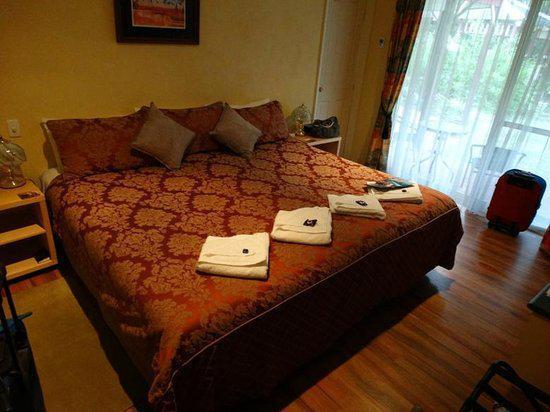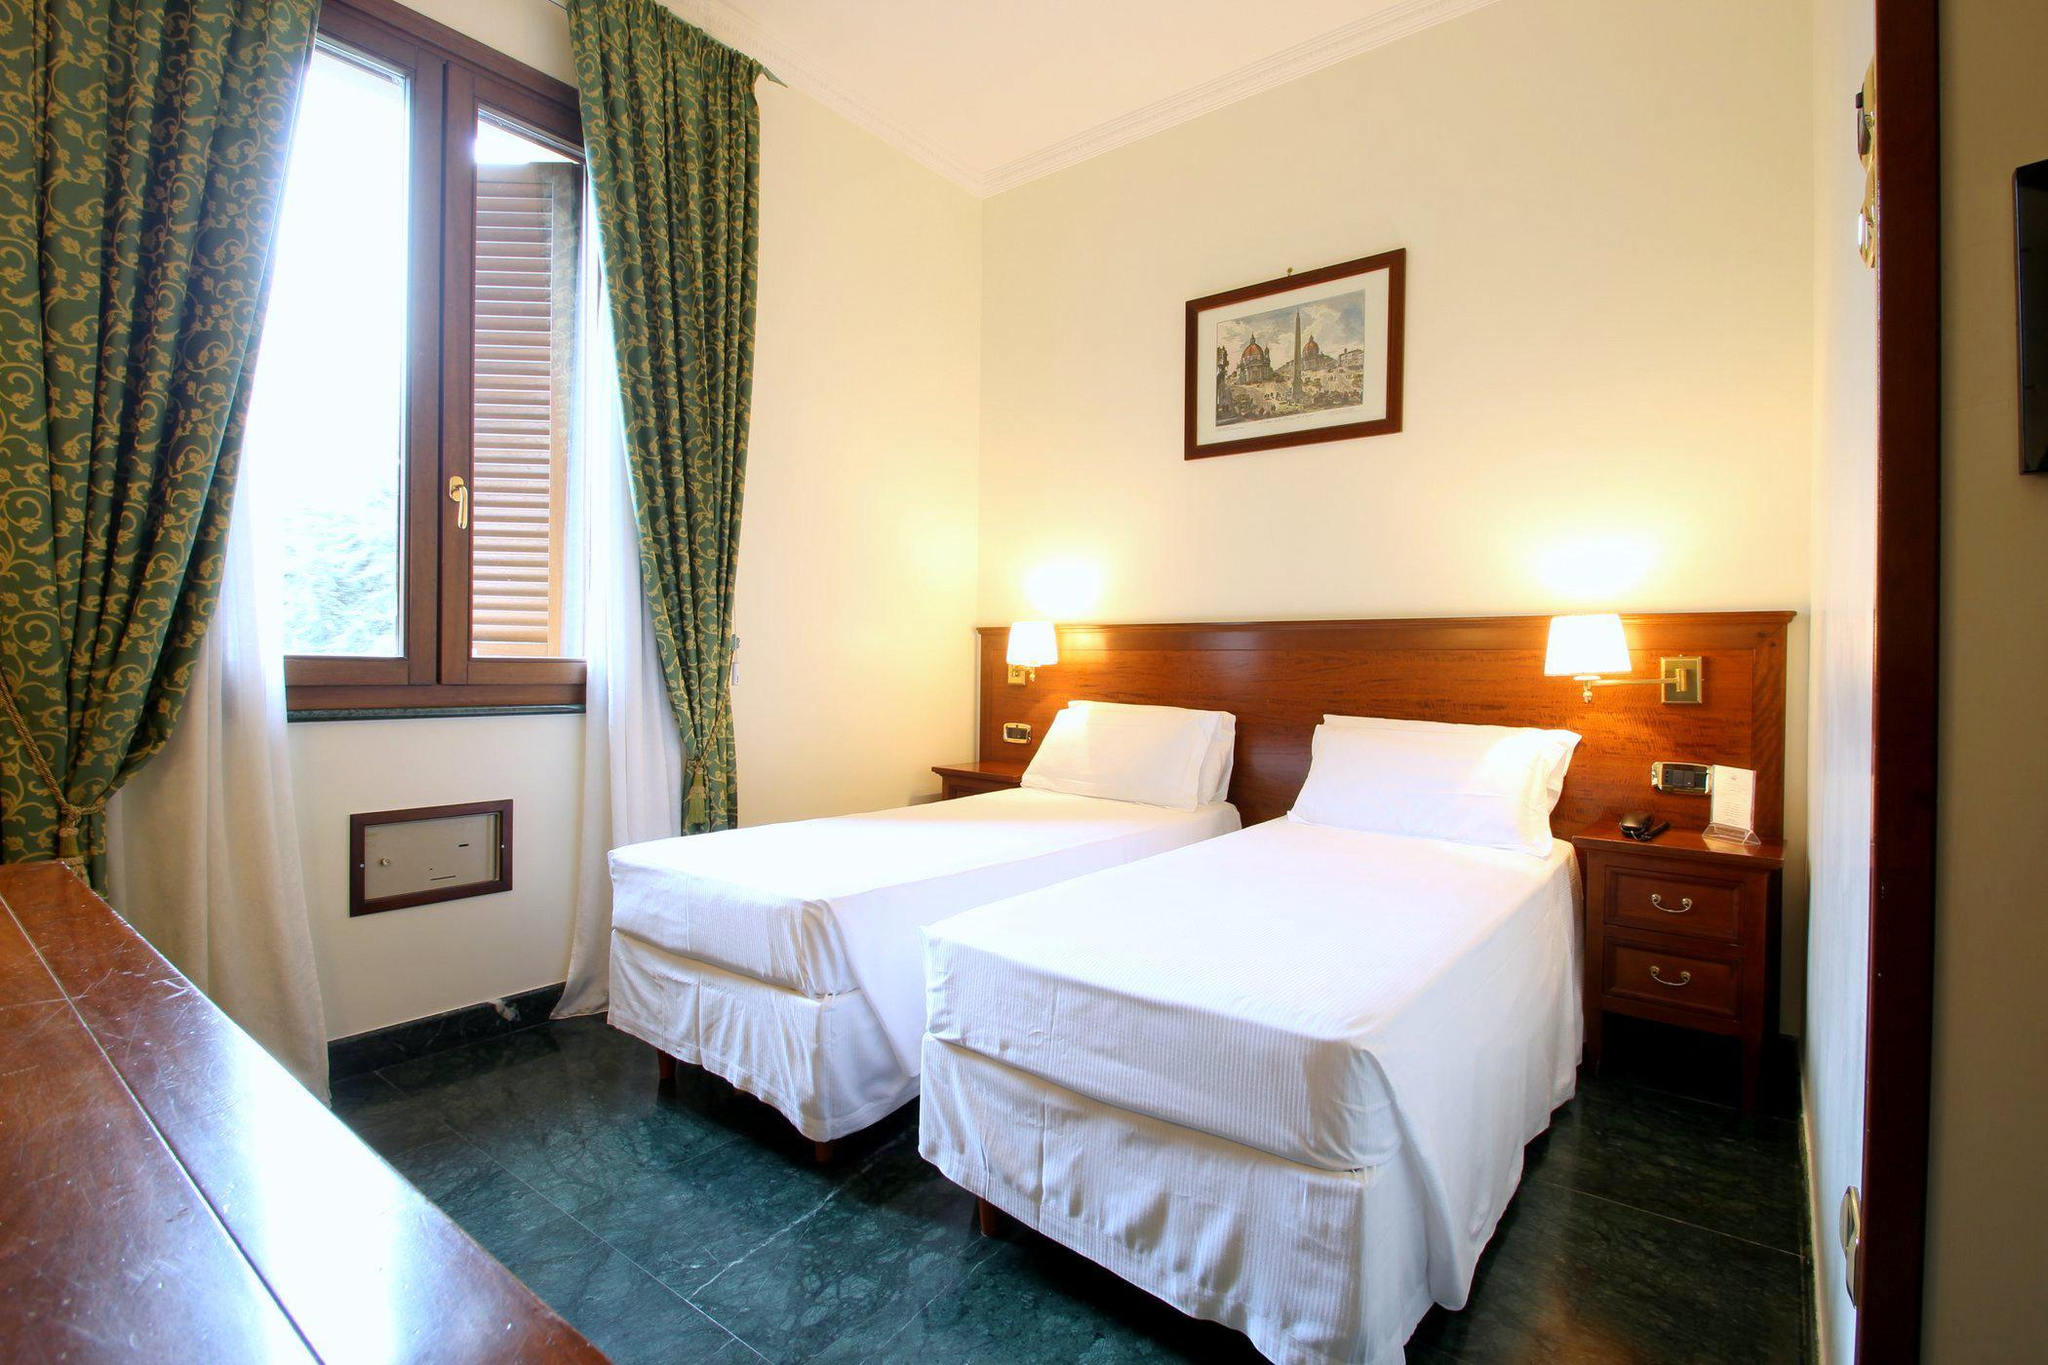The first image is the image on the left, the second image is the image on the right. Given the left and right images, does the statement "There are no less than three beds" hold true? Answer yes or no. Yes. The first image is the image on the left, the second image is the image on the right. Evaluate the accuracy of this statement regarding the images: "In 1 of the images, 1 bed is in front of a dimpled headboard.". Is it true? Answer yes or no. No. 